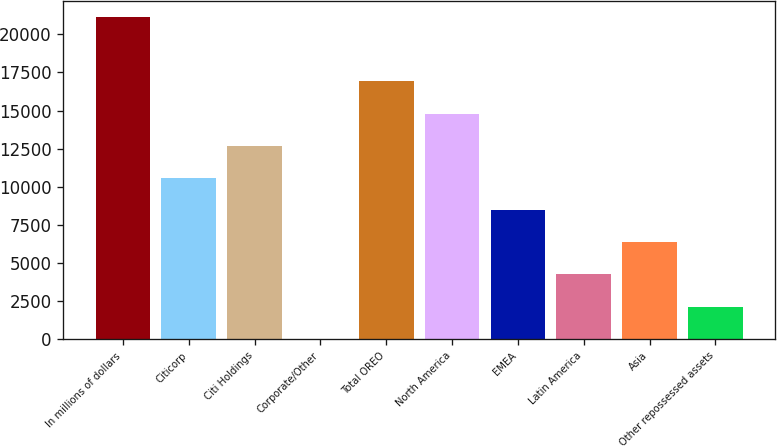<chart> <loc_0><loc_0><loc_500><loc_500><bar_chart><fcel>In millions of dollars<fcel>Citicorp<fcel>Citi Holdings<fcel>Corporate/Other<fcel>Total OREO<fcel>North America<fcel>EMEA<fcel>Latin America<fcel>Asia<fcel>Other repossessed assets<nl><fcel>21138<fcel>10576<fcel>12688.4<fcel>14<fcel>16913.2<fcel>14800.8<fcel>8463.6<fcel>4238.8<fcel>6351.2<fcel>2126.4<nl></chart> 